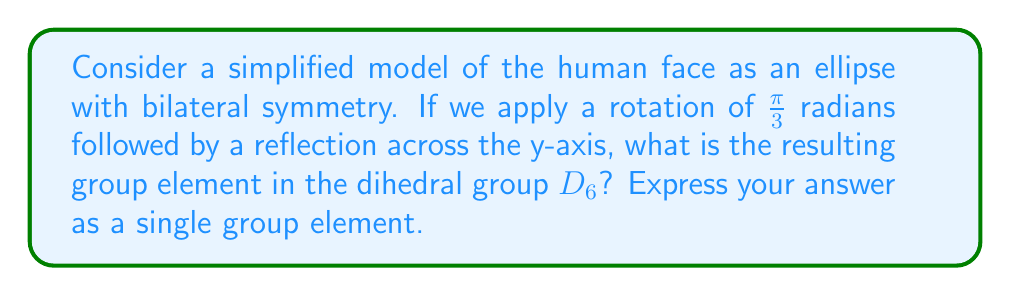What is the answer to this math problem? Let's approach this step-by-step:

1) First, recall that the dihedral group $D_6$ consists of 12 elements: 6 rotations and 6 reflections. We denote rotations by $r_k$ (where $k$ is the number of $\frac{\pi}{3}$ rotations) and reflections by $s_k$ (where $k$ is the number of $\frac{\pi}{3}$ rotations before the reflection).

2) The given transformation is a composition of two operations:
   a) A rotation of $\frac{\pi}{3}$ radians, which corresponds to $r_1$ in $D_6$.
   b) A reflection across the y-axis, which corresponds to $s_0$ in $D_6$.

3) In group theory, we apply these operations from right to left. So we need to calculate $s_0 \circ r_1$.

4) To compute this, we can use the general formula for $D_6$:
   $s_j \circ r_i = s_{j-i}$ (mod 6)

5) In our case, $j=0$ and $i=1$, so:
   $s_0 \circ r_1 = s_{0-1} = s_{-1} = s_5$ (since -1 ≡ 5 (mod 6))

6) Therefore, the resulting group element is $s_5$, which represents a reflection across a line that makes an angle of $5\frac{\pi}{3}$ with the positive x-axis.
Answer: $s_5$ 